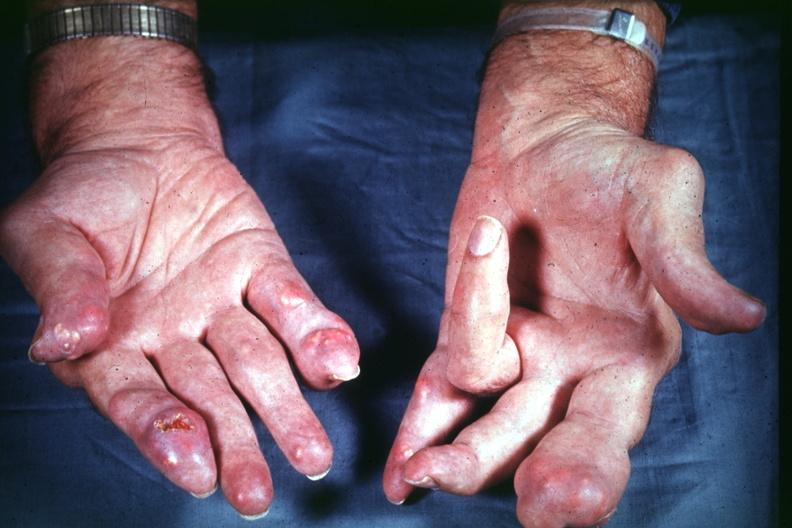what does this image show?
Answer the question using a single word or phrase. Good example source of gout 